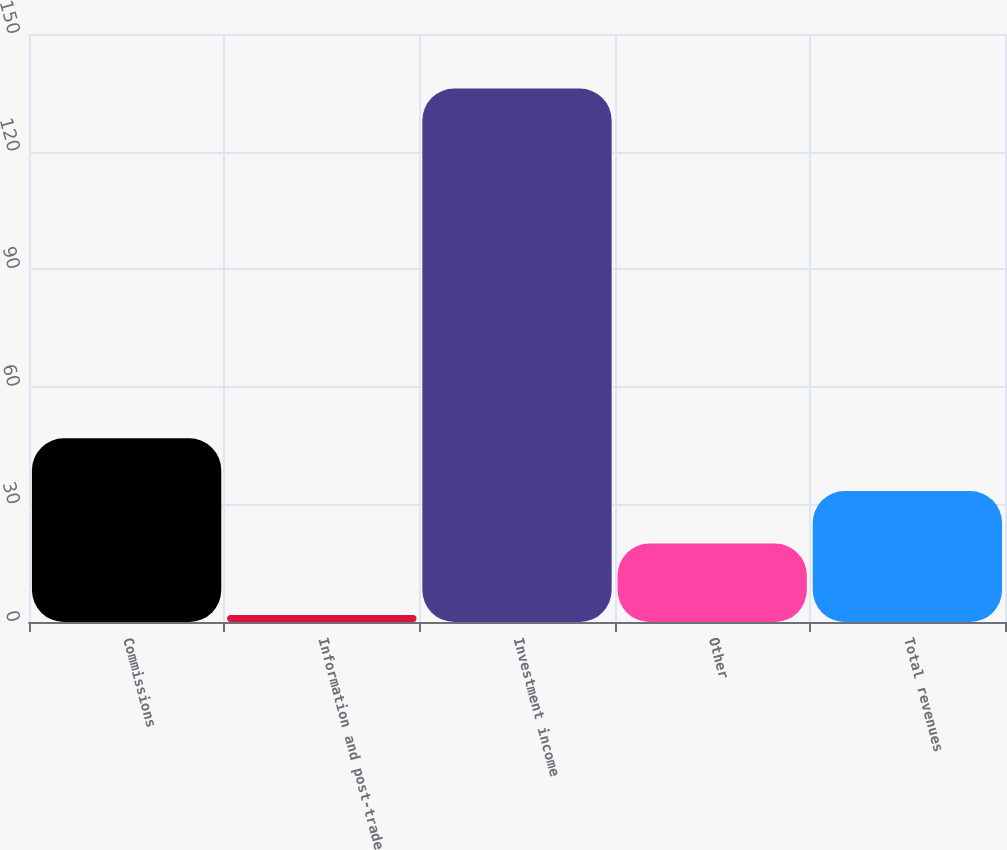<chart> <loc_0><loc_0><loc_500><loc_500><bar_chart><fcel>Commissions<fcel>Information and post-trade<fcel>Investment income<fcel>Other<fcel>Total revenues<nl><fcel>46.86<fcel>1.8<fcel>136.1<fcel>20<fcel>33.43<nl></chart> 